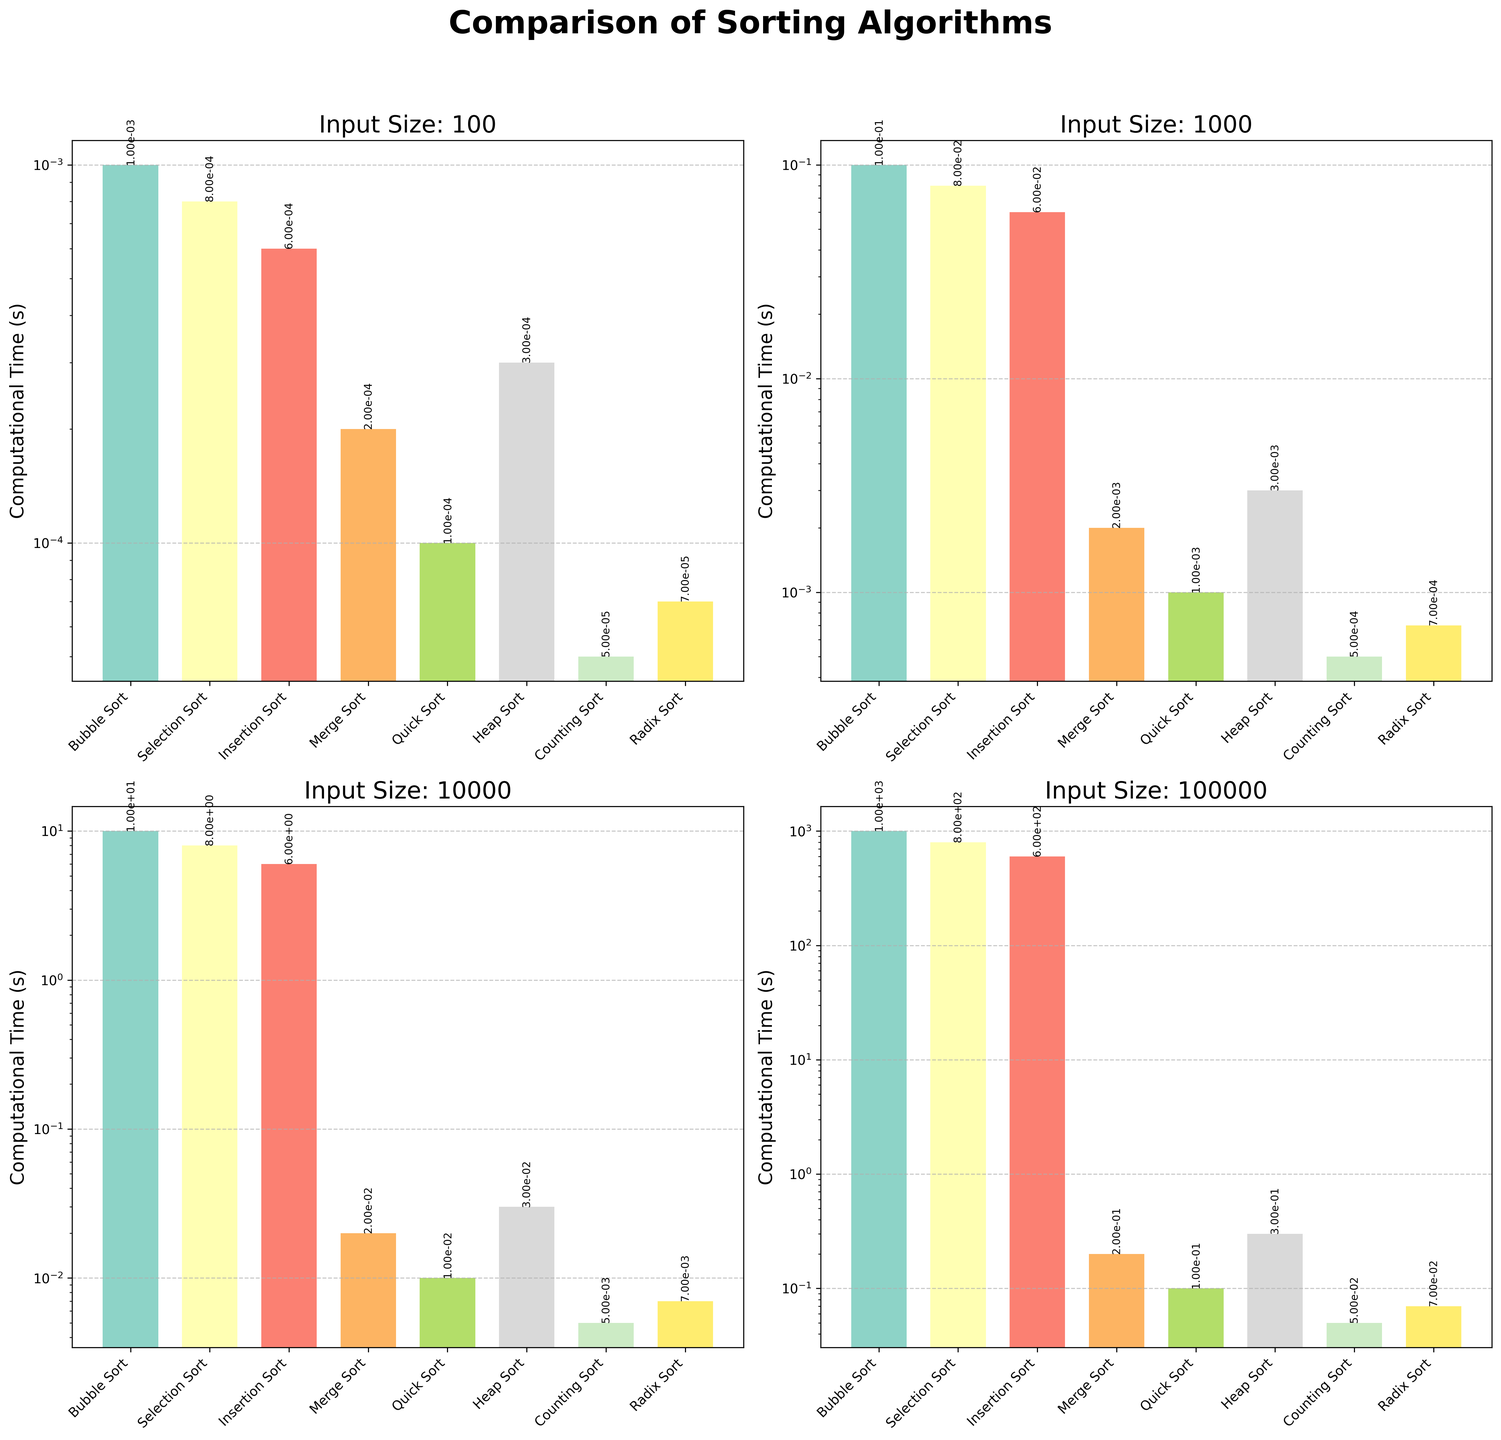What is the computational time of Bubble Sort for an input size of 100? From the subplots, the bar corresponding to Bubble Sort under the plot for input size 100 is labeled with its height. The value shown is approximately 0.001 seconds.
Answer: 0.001 seconds Which sorting algorithm is fastest for an input size of 100,000? Observing the plot for input size 100,000, the shortest bar corresponds to Counting Sort. The computational time shown near the top of the bar is 0.05 seconds, making it the fastest algorithm for this input size.
Answer: Counting Sort How does the computational time of Merge Sort compare between input sizes of 1,000 and 10,000? In the subplot for input size 1,000, the bar for Merge Sort shows a computational time of 0.002 seconds. In the subplot for input size 10,000, the bar for Merge Sort shows a computational time of 0.02 seconds. Merge Sort's time is 10 times higher for input size 10,000 compared to 1,000.
Answer: 10 times higher for 10,000 What is the average computational time of Heap Sort across all input sizes shown? The computational times for Heap Sort from the subplots are 0.0003, 0.003, 0.03, and 0.3 seconds. Adding these values gives 0.3333 seconds. Dividing by the number of input sizes (4) gives an average time of 0.083325 seconds.
Answer: 0.083325 seconds For an input size of 1,000, which algorithm is slower: Selection Sort or Insertion Sort? Observing the subplot for input size 1,000, the height of the bar for Selection Sort indicates a computational time of 0.08 seconds. The bar for Insertion Sort shows a value of 0.06 seconds. Thus, Selection Sort is slower than Insertion Sort for this input size.
Answer: Selection Sort Calculate the ratio of computational times between Quick Sort and Bubble Sort for an input size of 10,000. In the subplot for input size 10,000, Quick Sort has a computational time of 0.01 seconds and Bubble Sort has a computational time of 10 seconds. The ratio of Bubble Sort to Quick Sort is 10/0.01, which simplifies to 1000.
Answer: 1000 What is the visual difference in bar height between Counting Sort and Radix Sort for input size 100,000? In the subplot for input size 100,000, Counting Sort’s bar height represents 0.05 seconds, and Radix Sort’s bar height represents 0.07 seconds. The visual difference is the height corresponding to the difference in time, which is 0.02 seconds.
Answer: 0.02 seconds Which algorithm shows the most significant increase in computational time as input size increases from 100 to 100,000? Comparing all subplots, observe the relative increase in the height of bars for each algorithm. Bubble Sort increases from 0.001 to 1000 seconds, which is an increase of 999.999; this is the most substantial increase among the algorithms.
Answer: Bubble Sort Is the computational time difference between Selection Sort and Insertion Sort more noticeable at input size 1,000 or 100,000? At input size 1,000, the time difference is 0.08 - 0.06 = 0.02 seconds. At input size 100,000, the difference is 800 - 600 = 200 seconds. The computational time difference is more noticeable at input size 100,000.
Answer: 100,000 